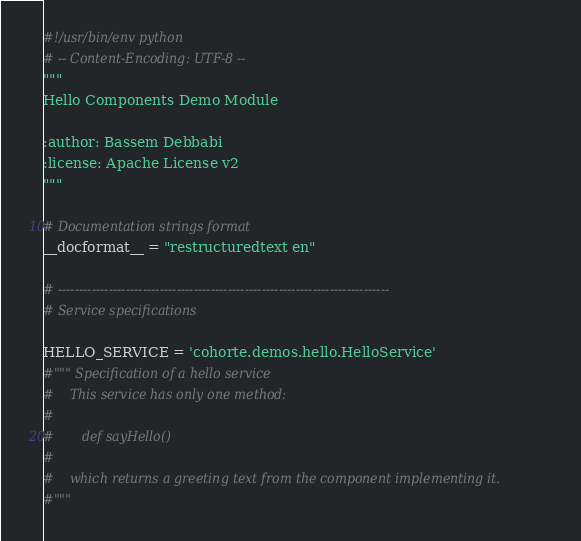Convert code to text. <code><loc_0><loc_0><loc_500><loc_500><_Python_>#!/usr/bin/env python
# -- Content-Encoding: UTF-8 --
"""
Hello Components Demo Module

:author: Bassem Debbabi
:license: Apache License v2
"""

# Documentation strings format
__docformat__ = "restructuredtext en"

# ------------------------------------------------------------------------------
# Service specifications

HELLO_SERVICE = 'cohorte.demos.hello.HelloService'
#""" Specification of a hello service
#    This service has only one method:
#       
#       def sayHello()
#    
#    which returns a greeting text from the component implementing it.
#"""</code> 